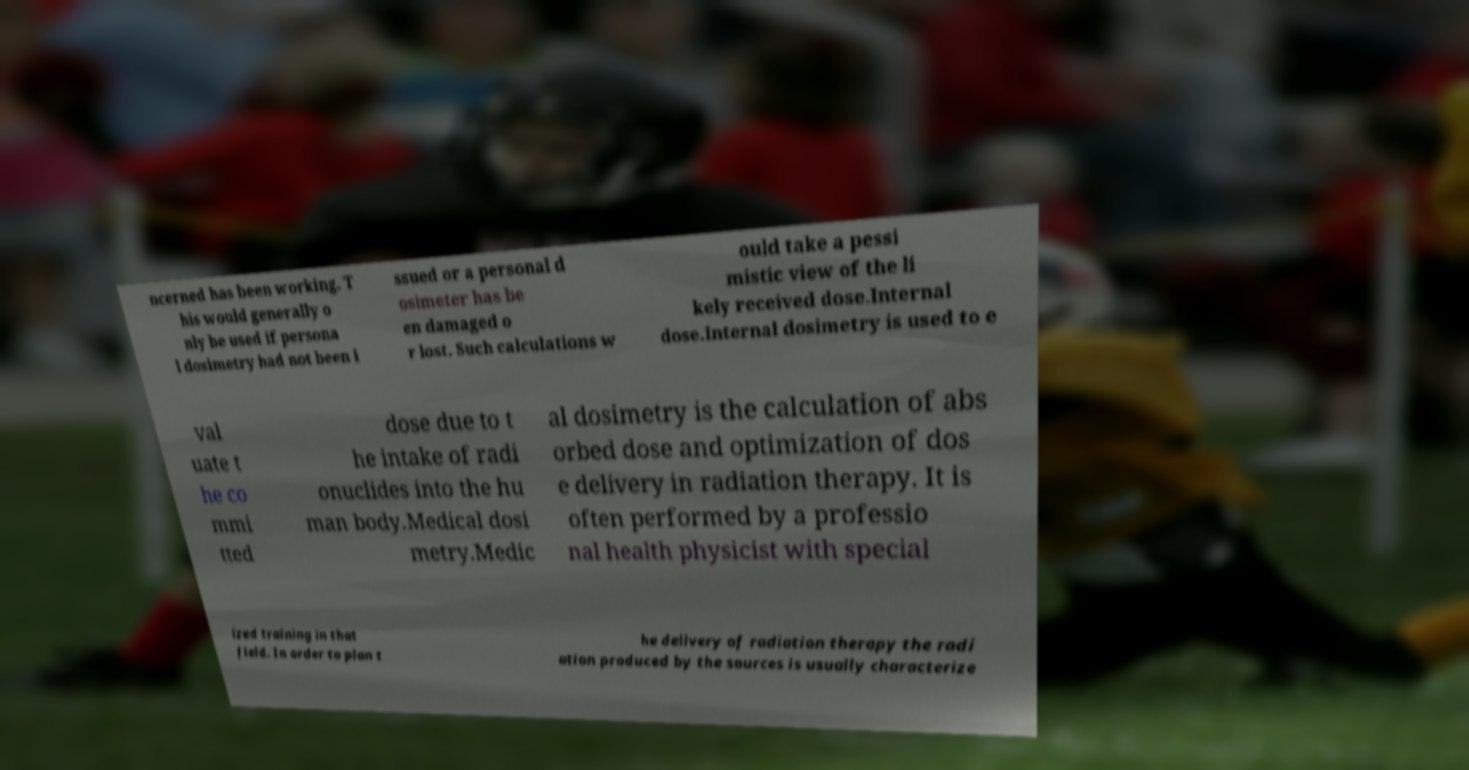Could you assist in decoding the text presented in this image and type it out clearly? ncerned has been working. T his would generally o nly be used if persona l dosimetry had not been i ssued or a personal d osimeter has be en damaged o r lost. Such calculations w ould take a pessi mistic view of the li kely received dose.Internal dose.Internal dosimetry is used to e val uate t he co mmi tted dose due to t he intake of radi onuclides into the hu man body.Medical dosi metry.Medic al dosimetry is the calculation of abs orbed dose and optimization of dos e delivery in radiation therapy. It is often performed by a professio nal health physicist with special ized training in that field. In order to plan t he delivery of radiation therapy the radi ation produced by the sources is usually characterize 